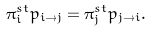<formula> <loc_0><loc_0><loc_500><loc_500>\pi ^ { s t } _ { i } p _ { i \rightarrow j } = \pi ^ { s t } _ { j } p _ { j \rightarrow i } .</formula> 